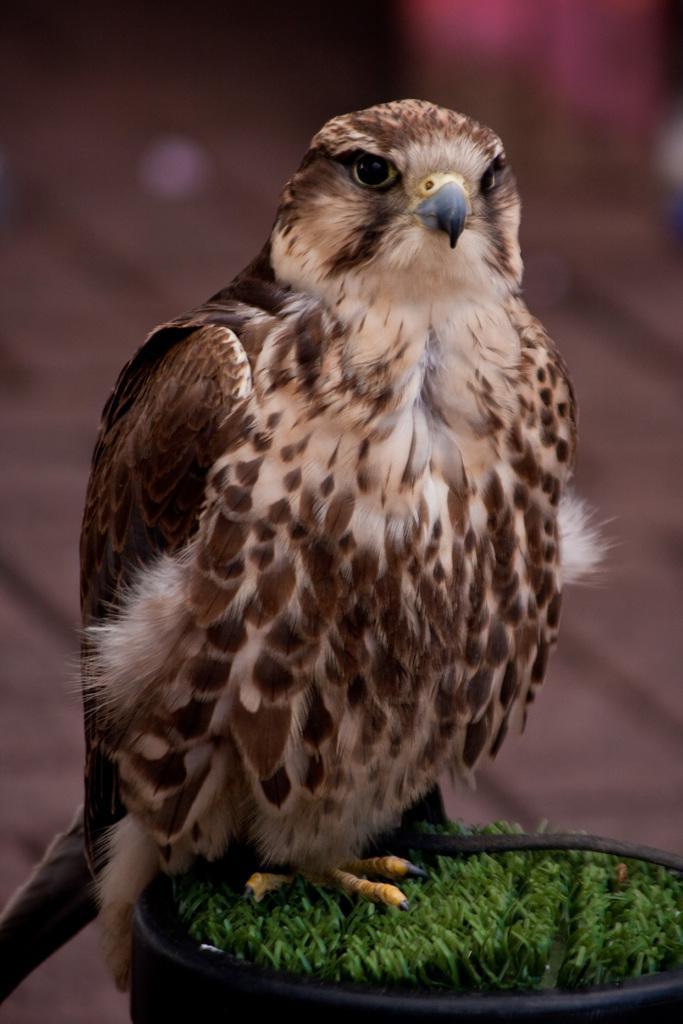Can you describe this image briefly? In the image we can see a bird, white and brown in color. The bird is sitting on the grass and the background is blurred. 